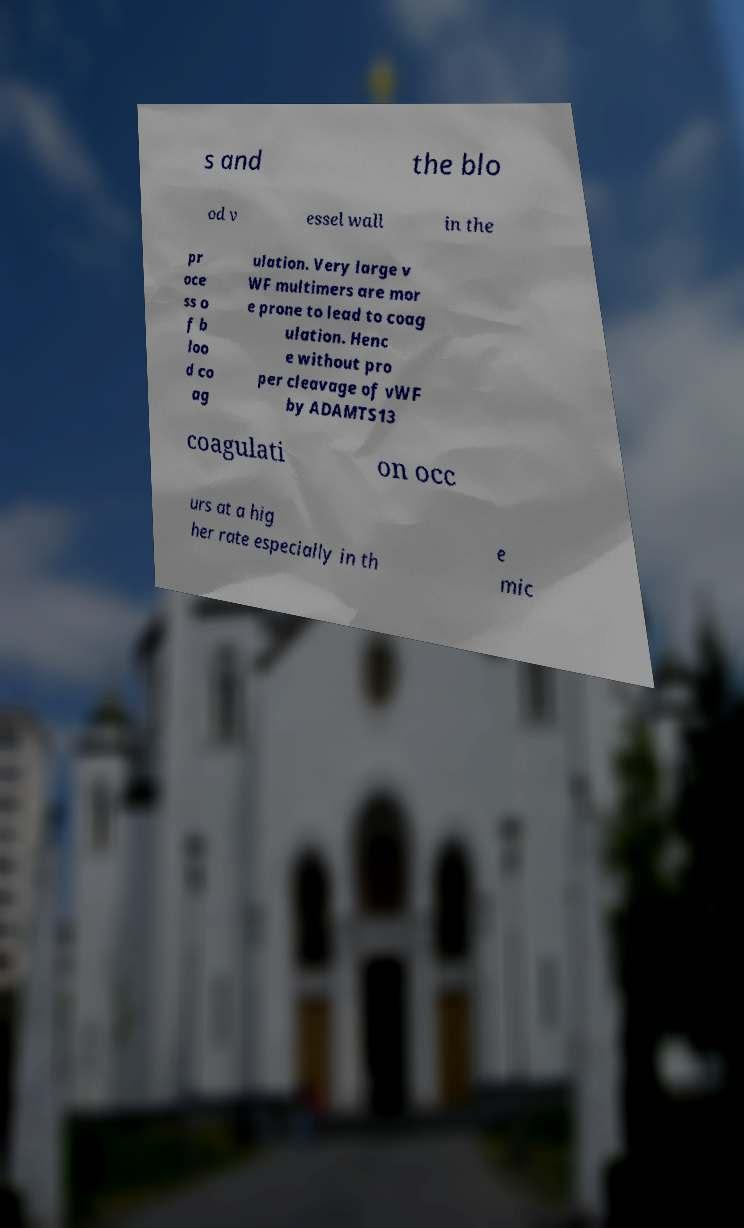I need the written content from this picture converted into text. Can you do that? s and the blo od v essel wall in the pr oce ss o f b loo d co ag ulation. Very large v WF multimers are mor e prone to lead to coag ulation. Henc e without pro per cleavage of vWF by ADAMTS13 coagulati on occ urs at a hig her rate especially in th e mic 